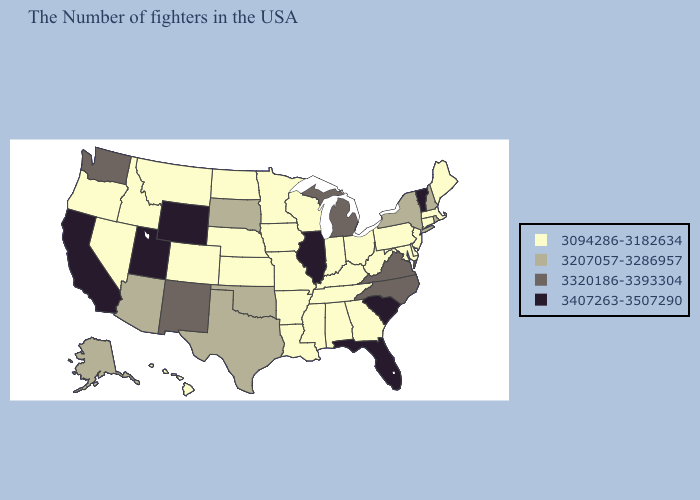Among the states that border Arkansas , does Tennessee have the highest value?
Answer briefly. No. Which states have the lowest value in the USA?
Answer briefly. Maine, Massachusetts, Connecticut, New Jersey, Delaware, Maryland, Pennsylvania, West Virginia, Ohio, Georgia, Kentucky, Indiana, Alabama, Tennessee, Wisconsin, Mississippi, Louisiana, Missouri, Arkansas, Minnesota, Iowa, Kansas, Nebraska, North Dakota, Colorado, Montana, Idaho, Nevada, Oregon, Hawaii. Which states hav the highest value in the South?
Short answer required. South Carolina, Florida. Does California have the lowest value in the West?
Be succinct. No. What is the value of Virginia?
Answer briefly. 3320186-3393304. Does Hawaii have the lowest value in the USA?
Answer briefly. Yes. What is the value of Washington?
Be succinct. 3320186-3393304. Does New Mexico have the lowest value in the USA?
Write a very short answer. No. Name the states that have a value in the range 3207057-3286957?
Concise answer only. Rhode Island, New Hampshire, New York, Oklahoma, Texas, South Dakota, Arizona, Alaska. Does Wisconsin have a higher value than Ohio?
Keep it brief. No. What is the value of Iowa?
Short answer required. 3094286-3182634. What is the value of Massachusetts?
Keep it brief. 3094286-3182634. Does Mississippi have the same value as New Mexico?
Quick response, please. No. What is the value of Iowa?
Keep it brief. 3094286-3182634. Which states have the lowest value in the USA?
Give a very brief answer. Maine, Massachusetts, Connecticut, New Jersey, Delaware, Maryland, Pennsylvania, West Virginia, Ohio, Georgia, Kentucky, Indiana, Alabama, Tennessee, Wisconsin, Mississippi, Louisiana, Missouri, Arkansas, Minnesota, Iowa, Kansas, Nebraska, North Dakota, Colorado, Montana, Idaho, Nevada, Oregon, Hawaii. 